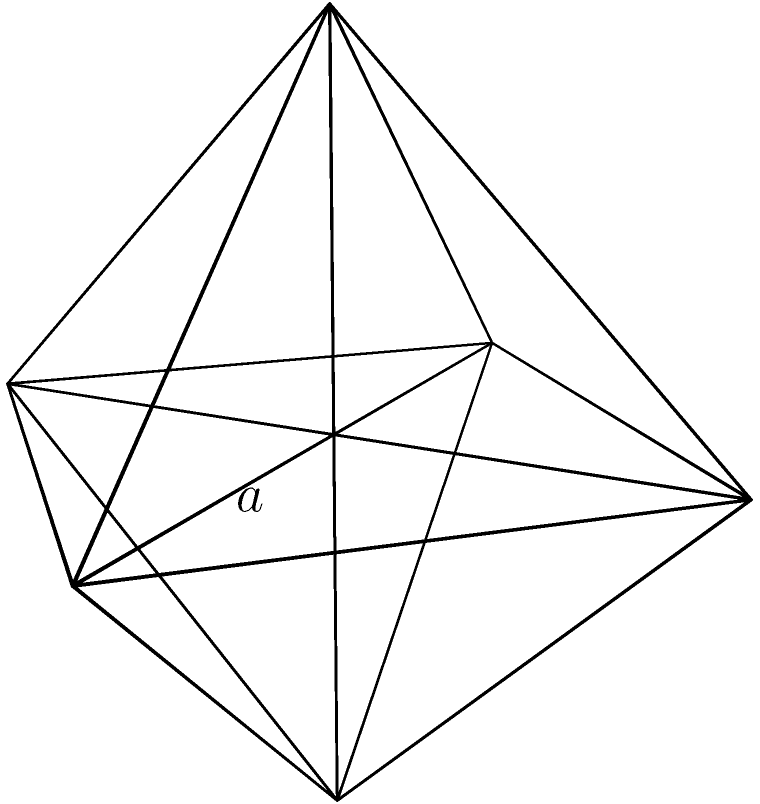A regular octahedron has an edge length of $a = 4$ cm. Calculate the total surface area of this octahedron. Let's approach this step-by-step:

1) A regular octahedron consists of 8 equilateral triangular faces.

2) The surface area will be the sum of the areas of these 8 triangles.

3) For an equilateral triangle with side length $a$, the area is given by:

   $$A_{triangle} = \frac{\sqrt{3}}{4}a^2$$

4) We have 8 such triangles, so the total surface area will be:

   $$SA_{octahedron} = 8 \cdot \frac{\sqrt{3}}{4}a^2$$

5) Simplifying:

   $$SA_{octahedron} = 2\sqrt{3}a^2$$

6) Now, let's substitute $a = 4$ cm:

   $$SA_{octahedron} = 2\sqrt{3}(4^2) = 2\sqrt{3}(16) = 32\sqrt{3}$$

7) Therefore, the surface area is $32\sqrt{3}$ square centimeters.
Answer: $32\sqrt{3}$ cm² 